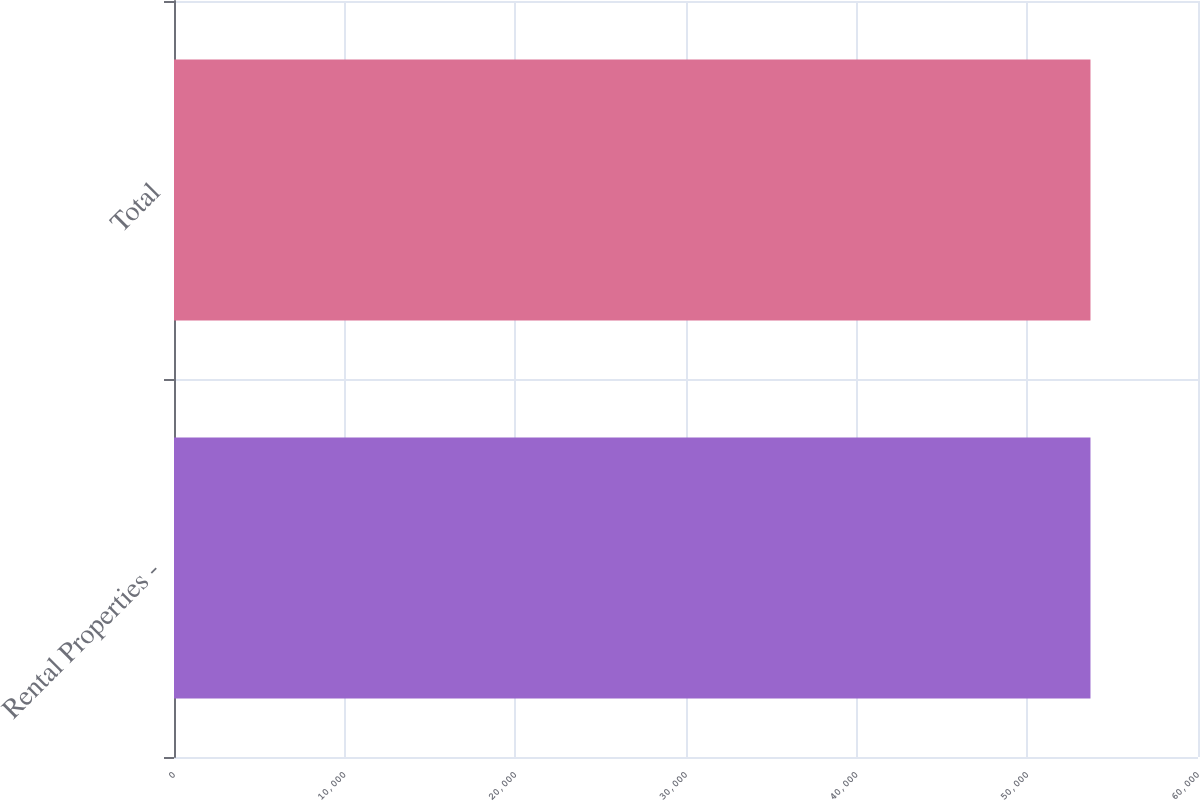Convert chart to OTSL. <chart><loc_0><loc_0><loc_500><loc_500><bar_chart><fcel>Rental Properties -<fcel>Total<nl><fcel>53700<fcel>53700.1<nl></chart> 